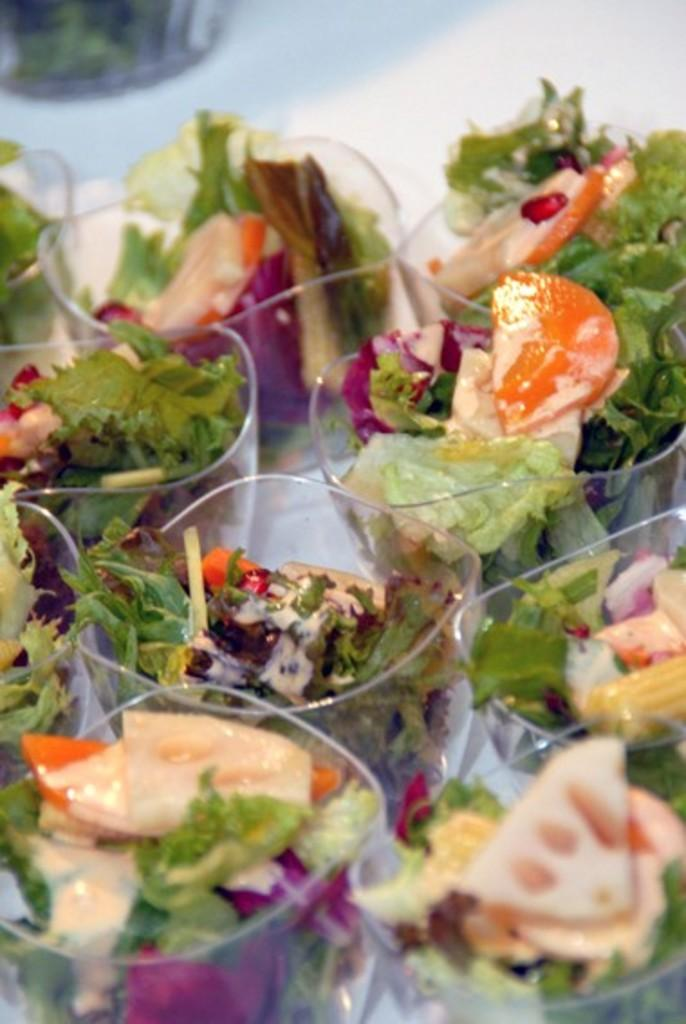What type of food is visible in the image? There is salad in the image. How is the salad served? The salad is served in cups. What is the color of the surface on which the cups are placed? The cups are placed on a white surface. Can you see a rabbit eating the salad in the image? There is no rabbit present in the image, and therefore no rabbit can be seen eating the salad. 